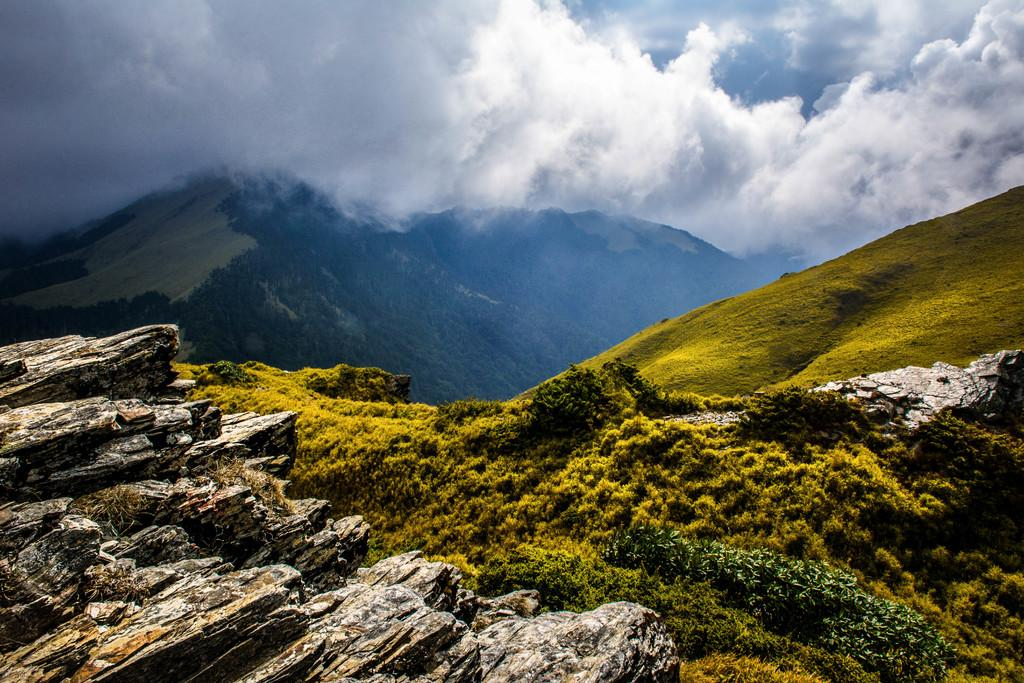What type of natural formation can be seen in the image? There are mountains in the image. What is visible in the background of the image? The sky is visible in the background of the image. What can be observed in the sky? Clouds are present in the sky. What type of arm is visible in the image? There is no arm present in the image; it features mountains and a sky with clouds. 